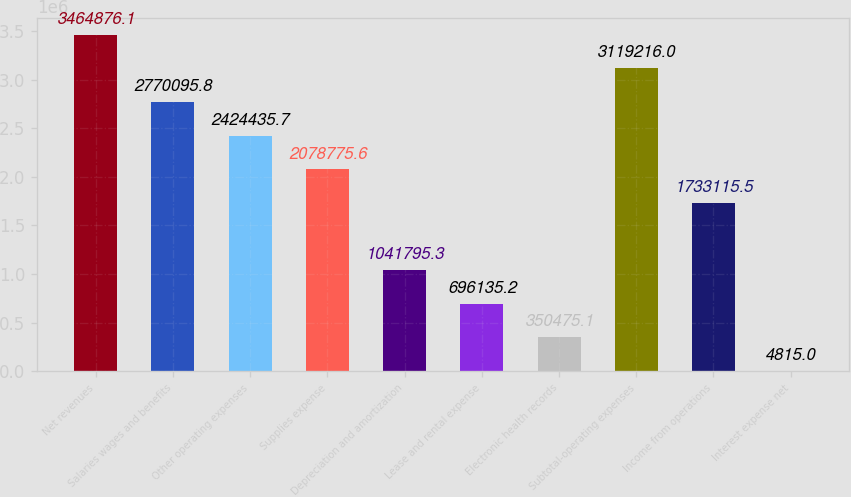<chart> <loc_0><loc_0><loc_500><loc_500><bar_chart><fcel>Net revenues<fcel>Salaries wages and benefits<fcel>Other operating expenses<fcel>Supplies expense<fcel>Depreciation and amortization<fcel>Lease and rental expense<fcel>Electronic health records<fcel>Subtotal-operating expenses<fcel>Income from operations<fcel>Interest expense net<nl><fcel>3.46488e+06<fcel>2.7701e+06<fcel>2.42444e+06<fcel>2.07878e+06<fcel>1.0418e+06<fcel>696135<fcel>350475<fcel>3.11922e+06<fcel>1.73312e+06<fcel>4815<nl></chart> 